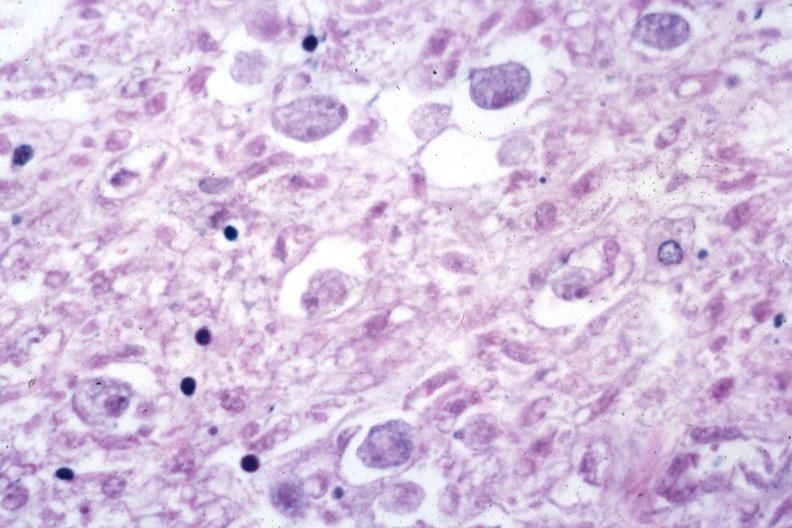where is this from?
Answer the question using a single word or phrase. Gastrointestinal system 